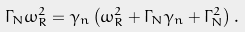<formula> <loc_0><loc_0><loc_500><loc_500>\Gamma _ { N } \omega _ { R } ^ { 2 } = \gamma _ { n } \left ( \omega _ { R } ^ { 2 } + \Gamma _ { N } \gamma _ { n } + \Gamma _ { N } ^ { 2 } \right ) .</formula> 